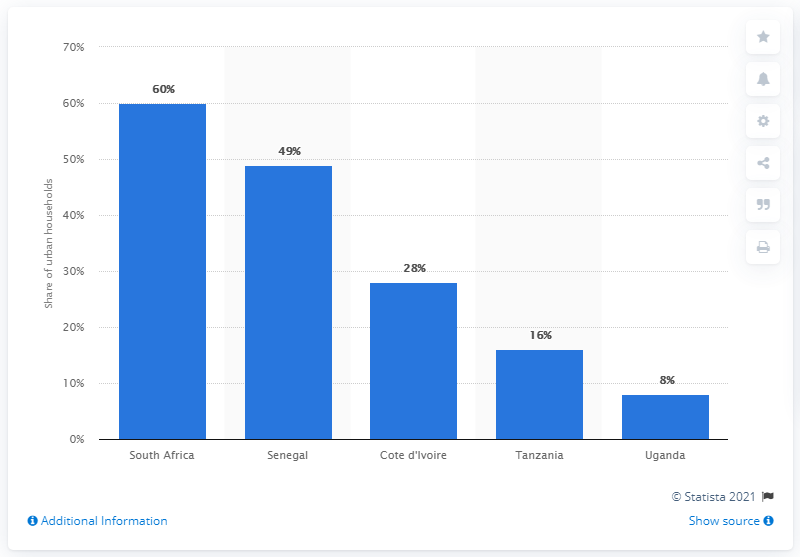Identify some key points in this picture. In Uganda, 8% of urban households had access to indoor plumbing, a type of sanitation system that provides clean water and efficient waste disposal. This is a significant improvement from the previous years, as indoor plumbing is often considered a sign of a developed country. 